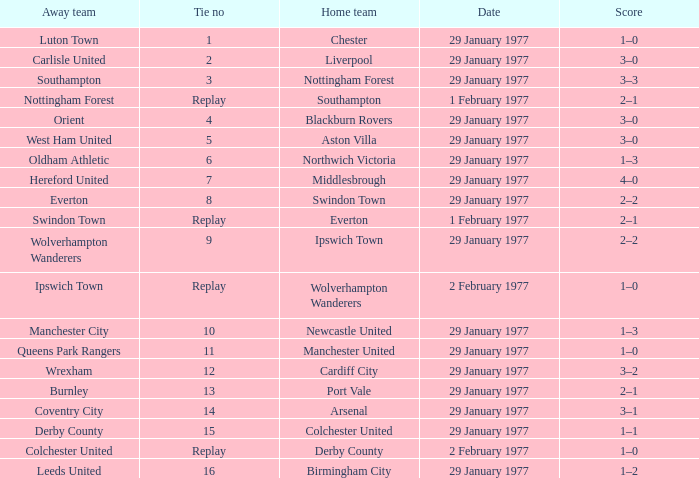Which away team has a tie number of 3? Southampton. 